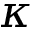<formula> <loc_0><loc_0><loc_500><loc_500>\kappa</formula> 